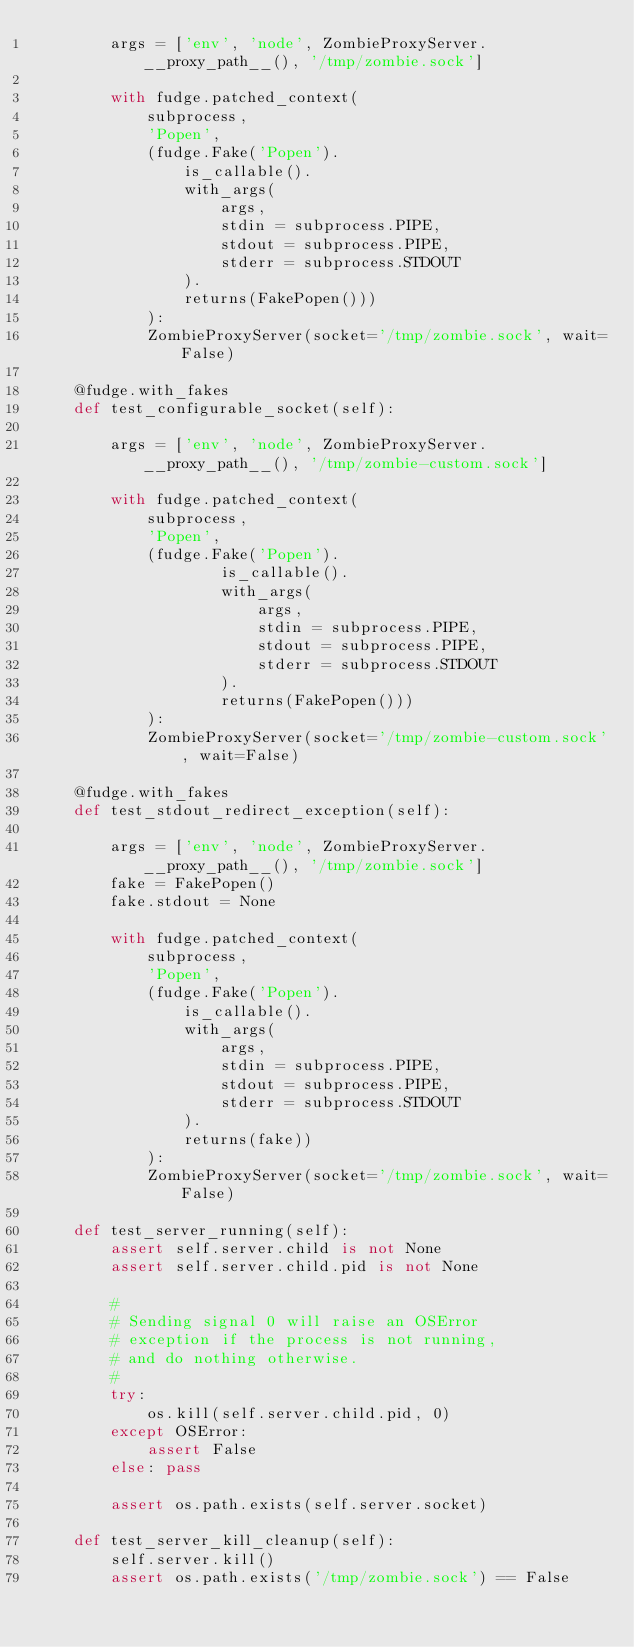<code> <loc_0><loc_0><loc_500><loc_500><_Python_>        args = ['env', 'node', ZombieProxyServer.__proxy_path__(), '/tmp/zombie.sock']

        with fudge.patched_context(
            subprocess,
            'Popen',
            (fudge.Fake('Popen').
                is_callable().
                with_args(
                    args,
                    stdin = subprocess.PIPE,
                    stdout = subprocess.PIPE,
                    stderr = subprocess.STDOUT
                ).
                returns(FakePopen()))
            ):
            ZombieProxyServer(socket='/tmp/zombie.sock', wait=False)

    @fudge.with_fakes
    def test_configurable_socket(self):

        args = ['env', 'node', ZombieProxyServer.__proxy_path__(), '/tmp/zombie-custom.sock']

        with fudge.patched_context(
            subprocess,
            'Popen',
            (fudge.Fake('Popen').
                    is_callable().
                    with_args(
                        args,
                        stdin = subprocess.PIPE,
                        stdout = subprocess.PIPE,
                        stderr = subprocess.STDOUT
                    ).
                    returns(FakePopen()))
            ):
            ZombieProxyServer(socket='/tmp/zombie-custom.sock', wait=False)

    @fudge.with_fakes
    def test_stdout_redirect_exception(self):

        args = ['env', 'node', ZombieProxyServer.__proxy_path__(), '/tmp/zombie.sock']
        fake = FakePopen()
        fake.stdout = None

        with fudge.patched_context(
            subprocess,
            'Popen',
            (fudge.Fake('Popen').
                is_callable().
                with_args(
                    args,
                    stdin = subprocess.PIPE,
                    stdout = subprocess.PIPE,
                    stderr = subprocess.STDOUT
                ).
                returns(fake))
            ):
            ZombieProxyServer(socket='/tmp/zombie.sock', wait=False)

    def test_server_running(self):
        assert self.server.child is not None
        assert self.server.child.pid is not None

        #
        # Sending signal 0 will raise an OSError
        # exception if the process is not running,
        # and do nothing otherwise.
        #
        try:
            os.kill(self.server.child.pid, 0)
        except OSError:
            assert False
        else: pass

        assert os.path.exists(self.server.socket)

    def test_server_kill_cleanup(self):
        self.server.kill()
        assert os.path.exists('/tmp/zombie.sock') == False
</code> 